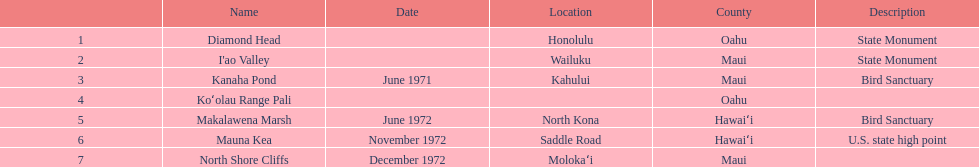Can you mention a location in hawaii besides mauna kea? Makalawena Marsh. 